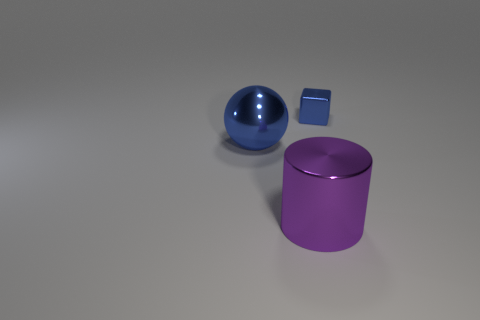Do the blue metal object that is behind the metal ball and the purple cylinder have the same size?
Your response must be concise. No. The shiny object that is to the left of the blue block and behind the purple thing is what color?
Make the answer very short. Blue. What number of metallic cylinders are behind the blue metallic thing that is in front of the small thing?
Provide a succinct answer. 0. Do the small thing and the purple metal object have the same shape?
Make the answer very short. No. Is there any other thing of the same color as the shiny block?
Make the answer very short. Yes. There is a purple shiny thing; is its shape the same as the large shiny object behind the big metallic cylinder?
Your answer should be very brief. No. There is a object that is in front of the big thing that is behind the big shiny thing on the right side of the shiny sphere; what is its color?
Offer a terse response. Purple. Are there any other things that are made of the same material as the blue sphere?
Offer a very short reply. Yes. There is a blue shiny thing to the left of the large purple shiny cylinder; does it have the same shape as the big purple object?
Offer a terse response. No. What is the small block made of?
Your response must be concise. Metal. 